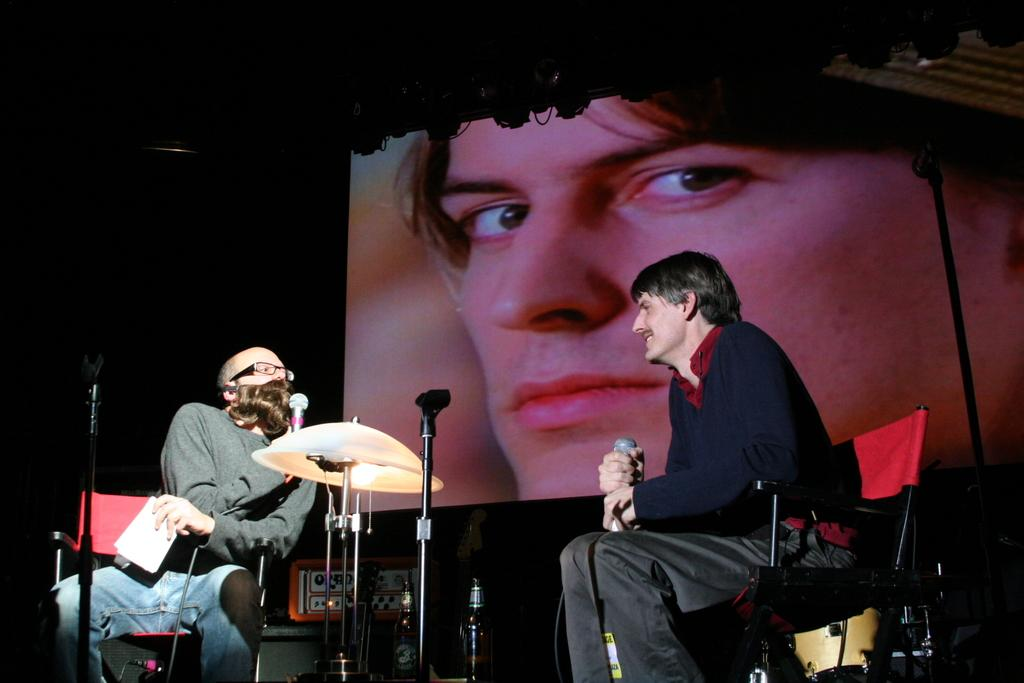How many people are in the image? There are two men in the image. What are the men doing in the image? The men are talking to each other. What can be seen around the men? There are objects around the men. What is visible in the background of the image? There is a picture on a screen in the background. What is present in front of the screen? There are lights in front of the screen. What type of mailbox can be seen in the image? There is no mailbox present in the image. Is the cast performing a dance routine in the image? There is no cast or dance routine depicted in the image; it features two men talking to each other. 